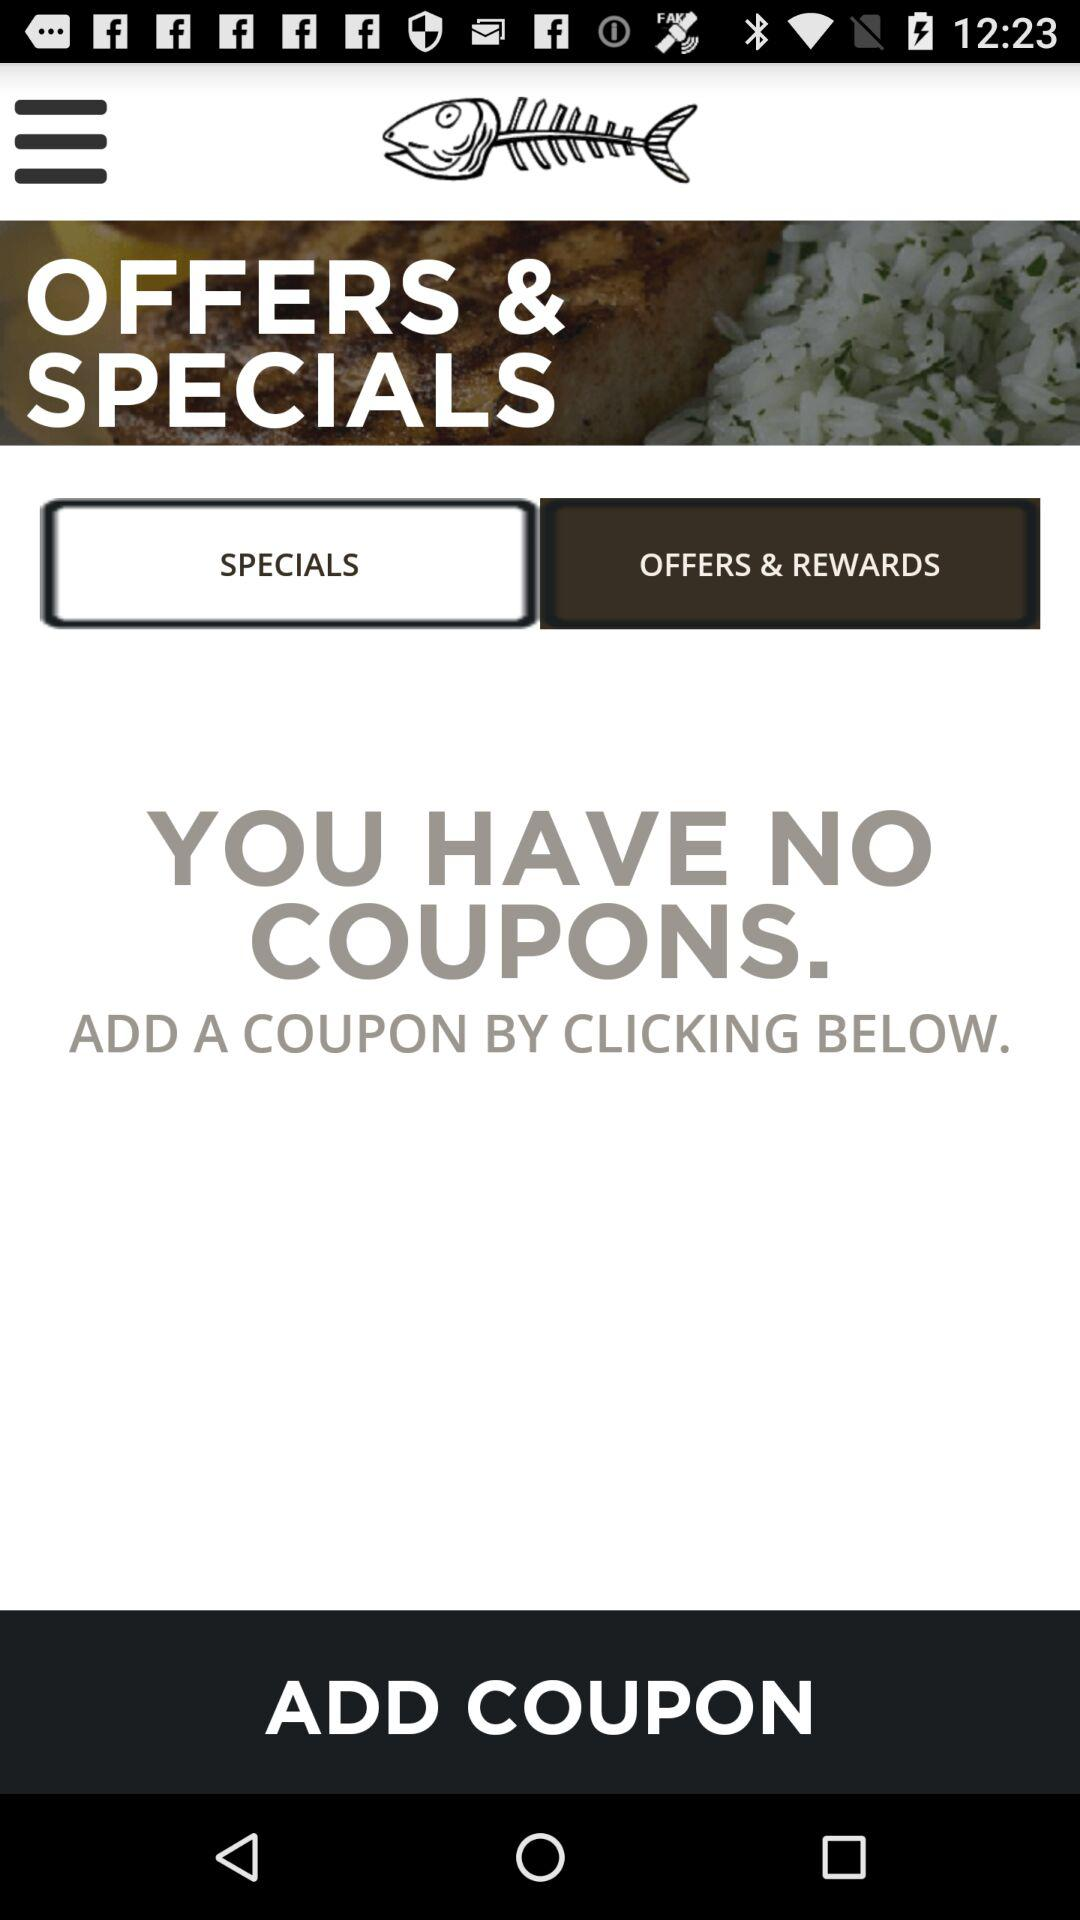What is the selected option? The selected option is "OFFERS & REWARDS". 